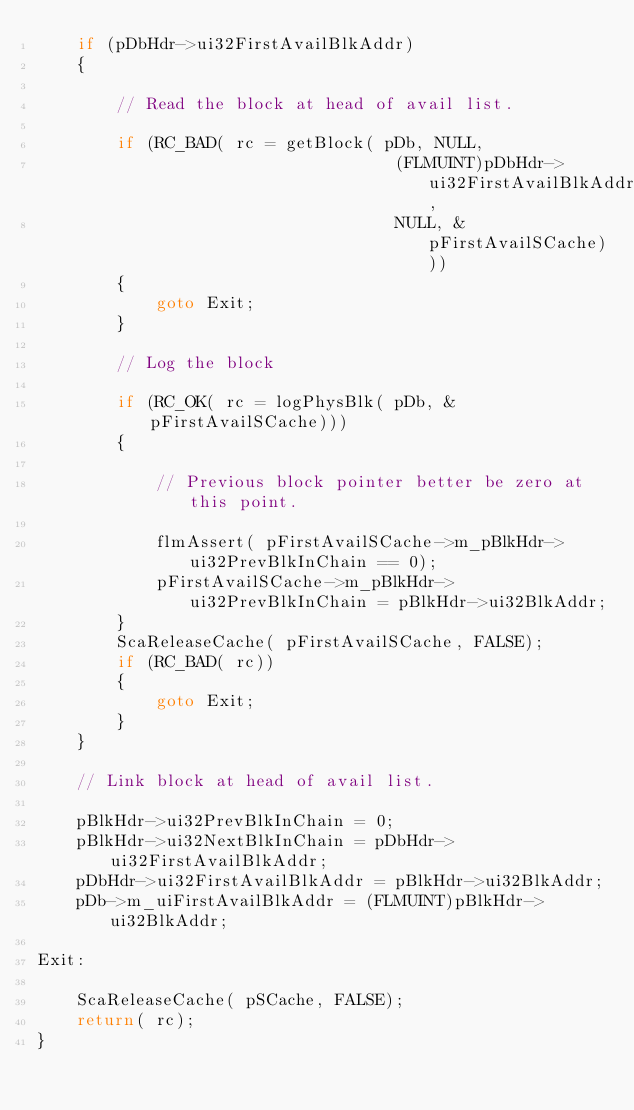Convert code to text. <code><loc_0><loc_0><loc_500><loc_500><_C++_>	if (pDbHdr->ui32FirstAvailBlkAddr)
	{

		// Read the block at head of avail list.

		if (RC_BAD( rc = getBlock( pDb, NULL,
									(FLMUINT)pDbHdr->ui32FirstAvailBlkAddr,
									NULL, &pFirstAvailSCache)))
		{
			goto Exit;
		}

		// Log the block

		if (RC_OK( rc = logPhysBlk( pDb, &pFirstAvailSCache)))
		{

			// Previous block pointer better be zero at this point.

			flmAssert( pFirstAvailSCache->m_pBlkHdr->ui32PrevBlkInChain == 0);
			pFirstAvailSCache->m_pBlkHdr->ui32PrevBlkInChain = pBlkHdr->ui32BlkAddr;
		}
		ScaReleaseCache( pFirstAvailSCache, FALSE);
		if (RC_BAD( rc))
		{
			goto Exit;
		}
	}

	// Link block at head of avail list.

	pBlkHdr->ui32PrevBlkInChain = 0;
	pBlkHdr->ui32NextBlkInChain = pDbHdr->ui32FirstAvailBlkAddr;
	pDbHdr->ui32FirstAvailBlkAddr = pBlkHdr->ui32BlkAddr;
	pDb->m_uiFirstAvailBlkAddr = (FLMUINT)pBlkHdr->ui32BlkAddr;

Exit:

	ScaReleaseCache( pSCache, FALSE);
	return( rc);
}
</code> 